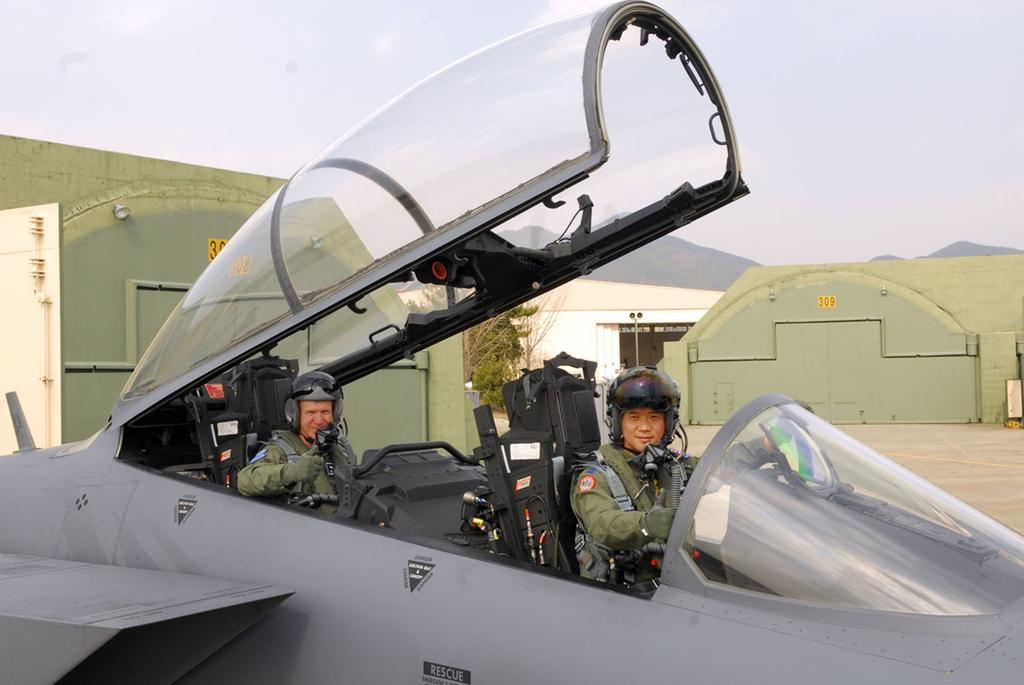<image>
Provide a brief description of the given image. People posing in an airplane with the word RESCUE on the side. 